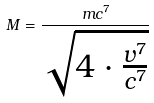<formula> <loc_0><loc_0><loc_500><loc_500>M = \frac { m c ^ { 7 } } { \sqrt { 4 \cdot \frac { v ^ { 7 } } { c ^ { 7 } } } }</formula> 